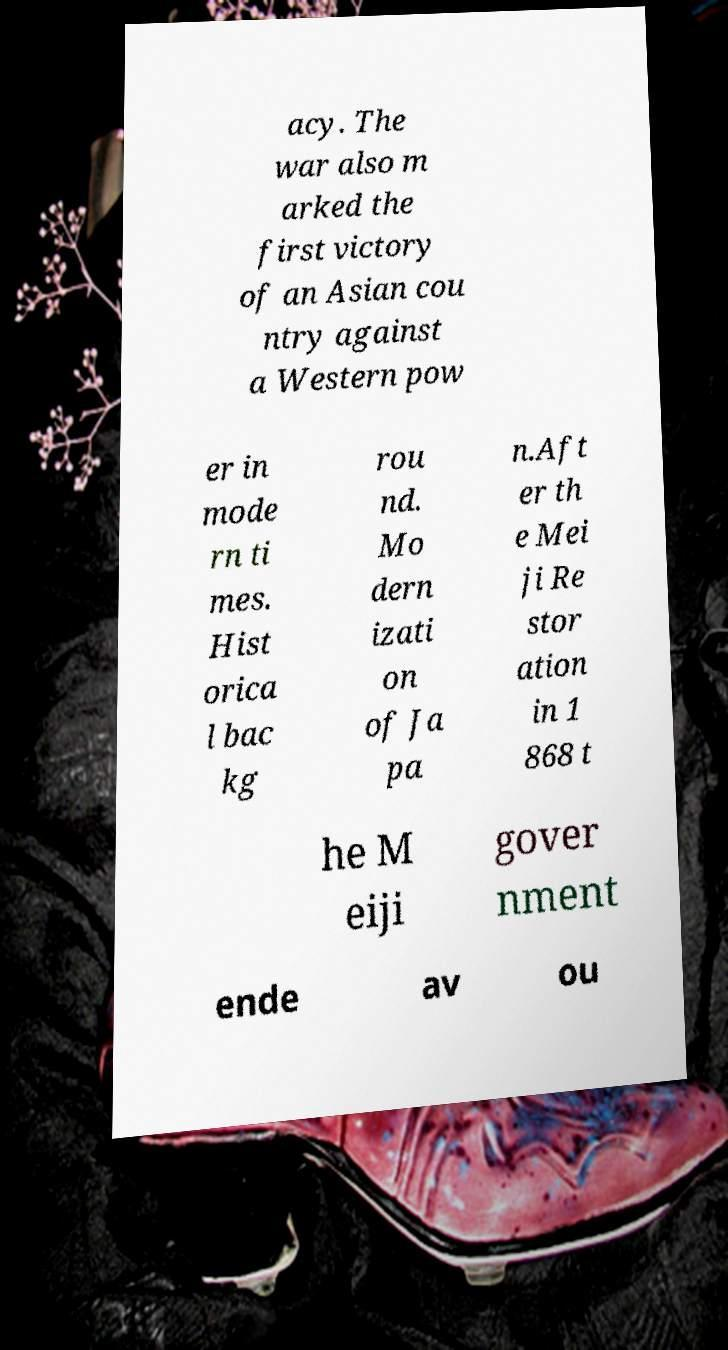What messages or text are displayed in this image? I need them in a readable, typed format. acy. The war also m arked the first victory of an Asian cou ntry against a Western pow er in mode rn ti mes. Hist orica l bac kg rou nd. Mo dern izati on of Ja pa n.Aft er th e Mei ji Re stor ation in 1 868 t he M eiji gover nment ende av ou 